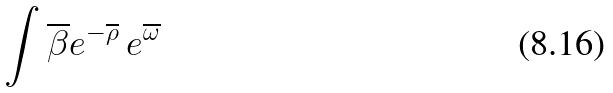Convert formula to latex. <formula><loc_0><loc_0><loc_500><loc_500>\int \overline { \beta } e ^ { - \overline { \rho } } \, e ^ { \overline { \omega } }</formula> 